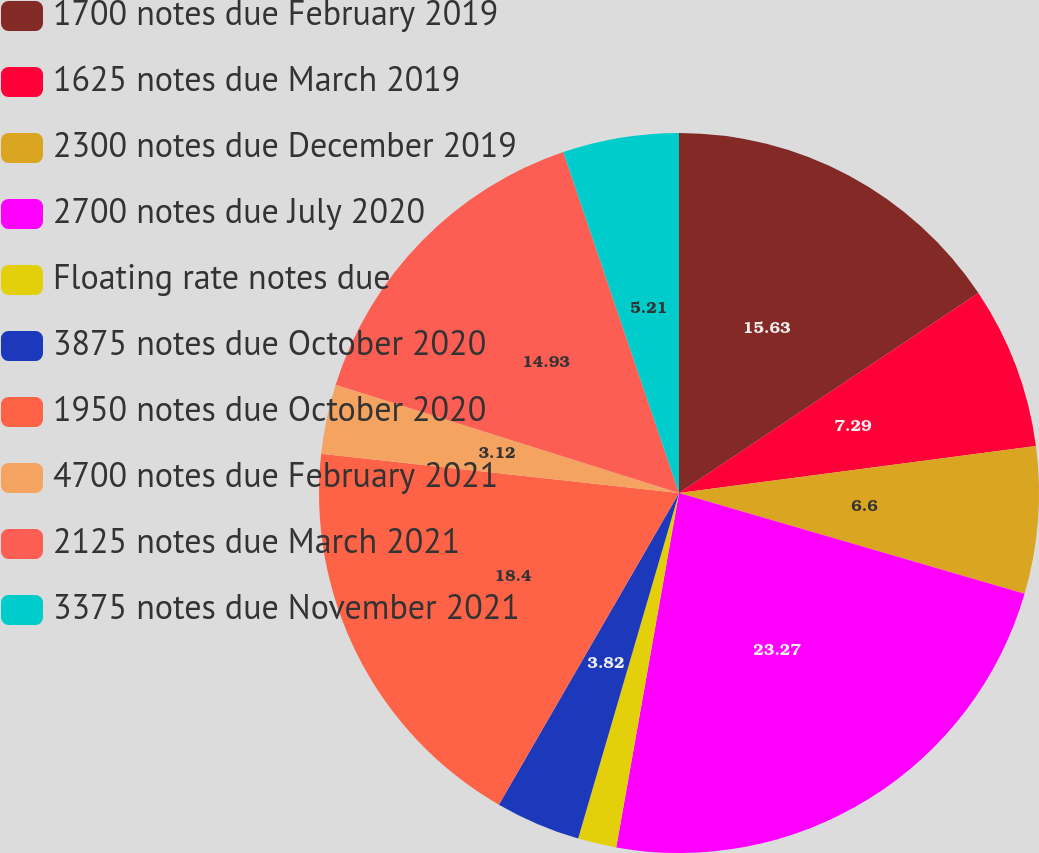Convert chart. <chart><loc_0><loc_0><loc_500><loc_500><pie_chart><fcel>1700 notes due February 2019<fcel>1625 notes due March 2019<fcel>2300 notes due December 2019<fcel>2700 notes due July 2020<fcel>Floating rate notes due<fcel>3875 notes due October 2020<fcel>1950 notes due October 2020<fcel>4700 notes due February 2021<fcel>2125 notes due March 2021<fcel>3375 notes due November 2021<nl><fcel>15.63%<fcel>7.29%<fcel>6.6%<fcel>23.27%<fcel>1.73%<fcel>3.82%<fcel>18.4%<fcel>3.12%<fcel>14.93%<fcel>5.21%<nl></chart> 